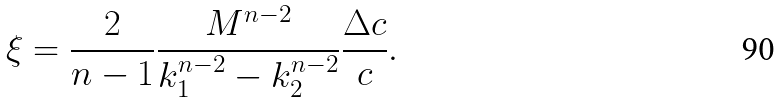Convert formula to latex. <formula><loc_0><loc_0><loc_500><loc_500>\xi = \frac { 2 } { n - 1 } \frac { M ^ { n - 2 } } { k _ { 1 } ^ { n - 2 } - k _ { 2 } ^ { n - 2 } } \frac { \Delta c } { c } .</formula> 